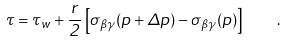Convert formula to latex. <formula><loc_0><loc_0><loc_500><loc_500>\tau = \tau _ { w } + \frac { r } { 2 } \left [ \sigma _ { \beta \gamma } ( p + \Delta p ) - \sigma _ { \beta \gamma } ( p ) \right ] \quad .</formula> 